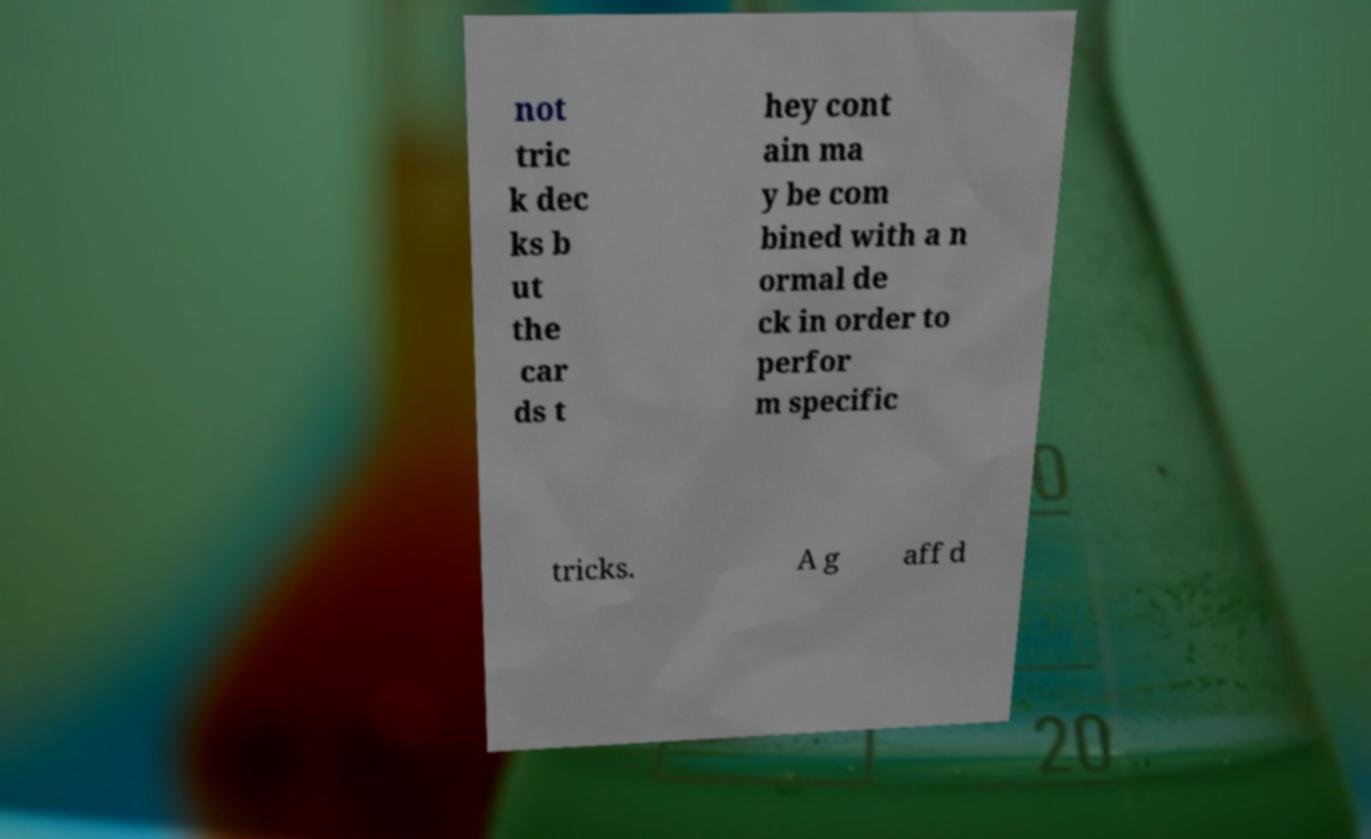Can you accurately transcribe the text from the provided image for me? not tric k dec ks b ut the car ds t hey cont ain ma y be com bined with a n ormal de ck in order to perfor m specific tricks. A g aff d 